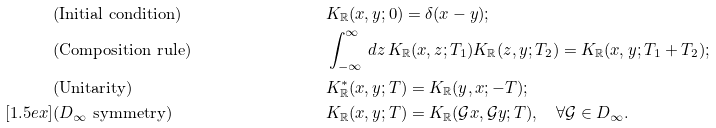Convert formula to latex. <formula><loc_0><loc_0><loc_500><loc_500>& \text {(Initial condition)} & \quad & K _ { \mathbb { R } } ( x , y ; 0 ) = \delta ( x - y ) ; & \\ & \text {(Composition rule)} & \quad & \int _ { - \infty } ^ { \infty } \, d z \, K _ { \mathbb { R } } ( x , z ; T _ { 1 } ) K _ { \mathbb { R } } ( z , y ; T _ { 2 } ) = K _ { \mathbb { R } } ( x , y ; T _ { 1 } + T _ { 2 } ) ; & \\ & \text {(Unitarity)} & \quad & K _ { \mathbb { R } } ^ { \ast } ( x , y ; T ) = K _ { \mathbb { R } } ( y , x ; - T ) ; & \\ [ 1 . 5 e x ] & \text {($D_{\infty}$ symmetry)} & \quad & K _ { \mathbb { R } } ( x , y ; T ) = K _ { \mathbb { R } } ( \mathcal { G } x , \mathcal { G } y ; T ) , \quad \forall \mathcal { G } \in D _ { \infty } . &</formula> 